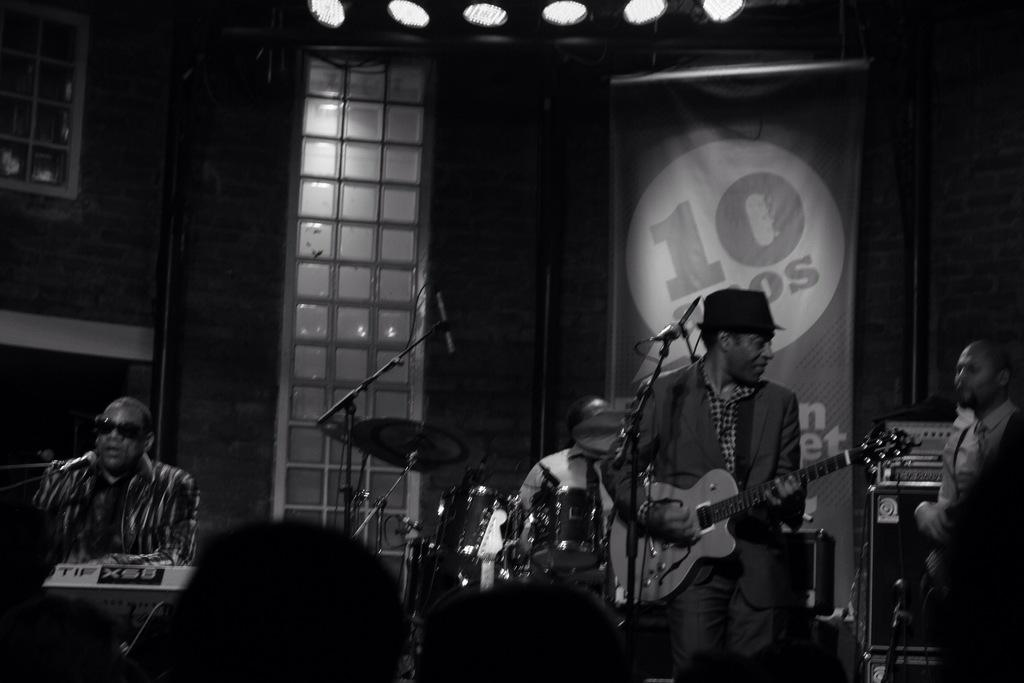How many people are in the image? There are four persons in the image. What are the four persons doing in the image? The four persons are playing music. Can you describe the presence of other people in the image? Yes, there is an audience in the image. What type of mist can be seen surrounding the musicians in the image? There is no mist present in the image; it features four persons playing music and an audience. What kind of pie is being served to the audience in the image? There is no pie present in the image; it only features four persons playing music and an audience. 